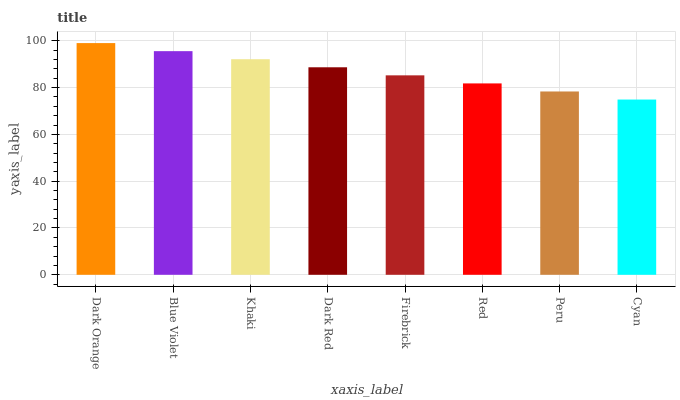Is Blue Violet the minimum?
Answer yes or no. No. Is Blue Violet the maximum?
Answer yes or no. No. Is Dark Orange greater than Blue Violet?
Answer yes or no. Yes. Is Blue Violet less than Dark Orange?
Answer yes or no. Yes. Is Blue Violet greater than Dark Orange?
Answer yes or no. No. Is Dark Orange less than Blue Violet?
Answer yes or no. No. Is Dark Red the high median?
Answer yes or no. Yes. Is Firebrick the low median?
Answer yes or no. Yes. Is Firebrick the high median?
Answer yes or no. No. Is Dark Orange the low median?
Answer yes or no. No. 